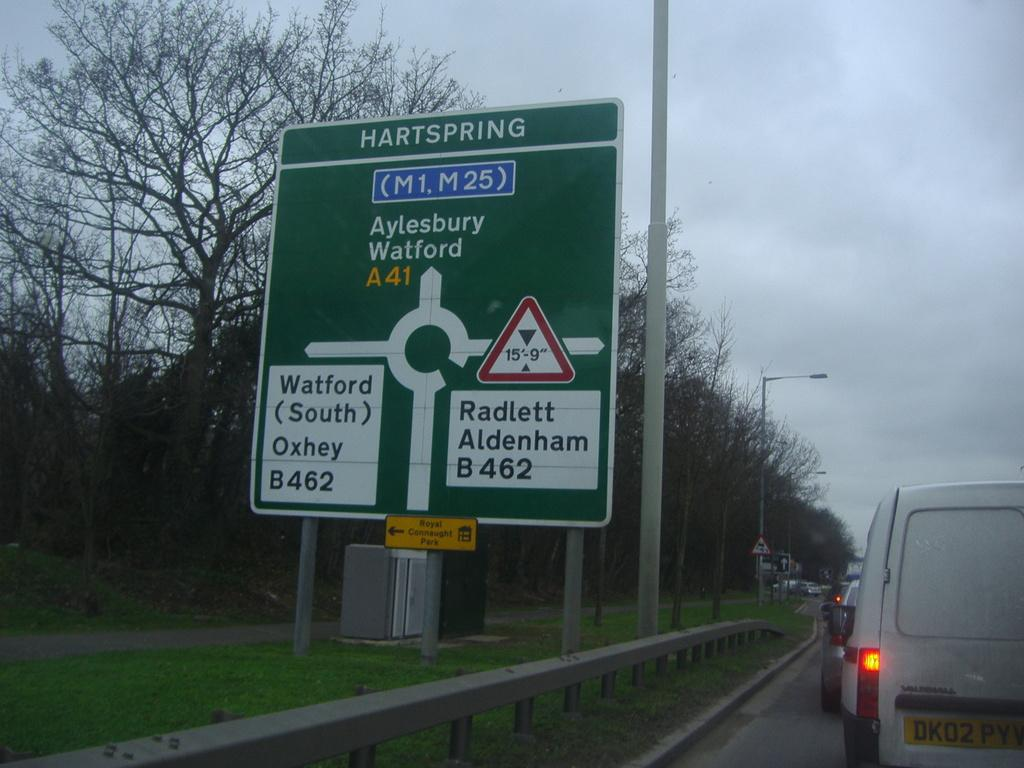<image>
Present a compact description of the photo's key features. The city that the road sign is in is Hartspring 